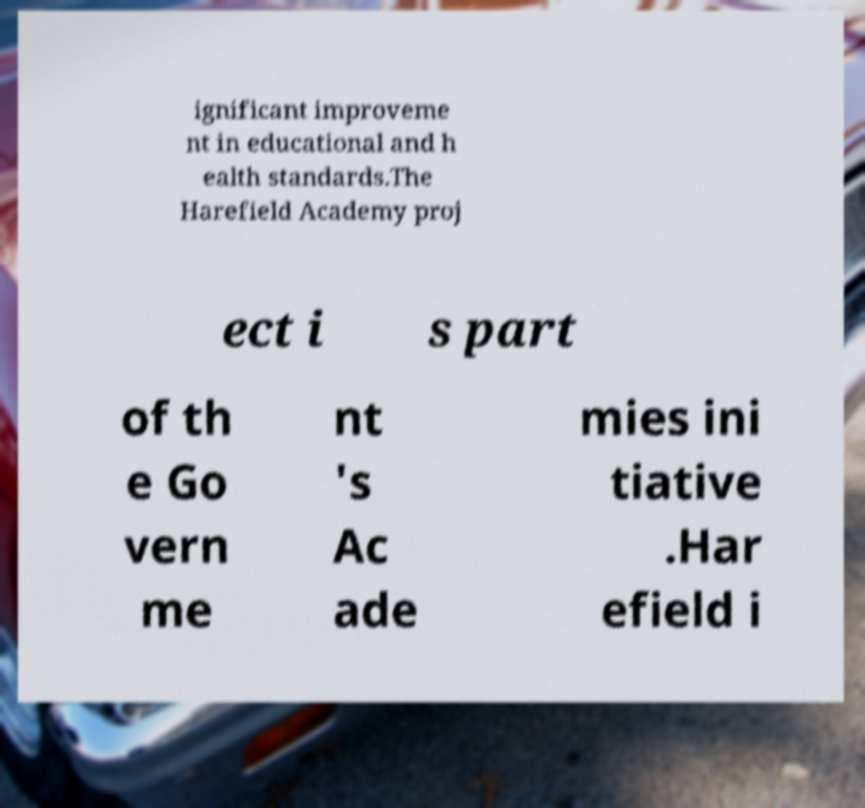Please identify and transcribe the text found in this image. ignificant improveme nt in educational and h ealth standards.The Harefield Academy proj ect i s part of th e Go vern me nt 's Ac ade mies ini tiative .Har efield i 